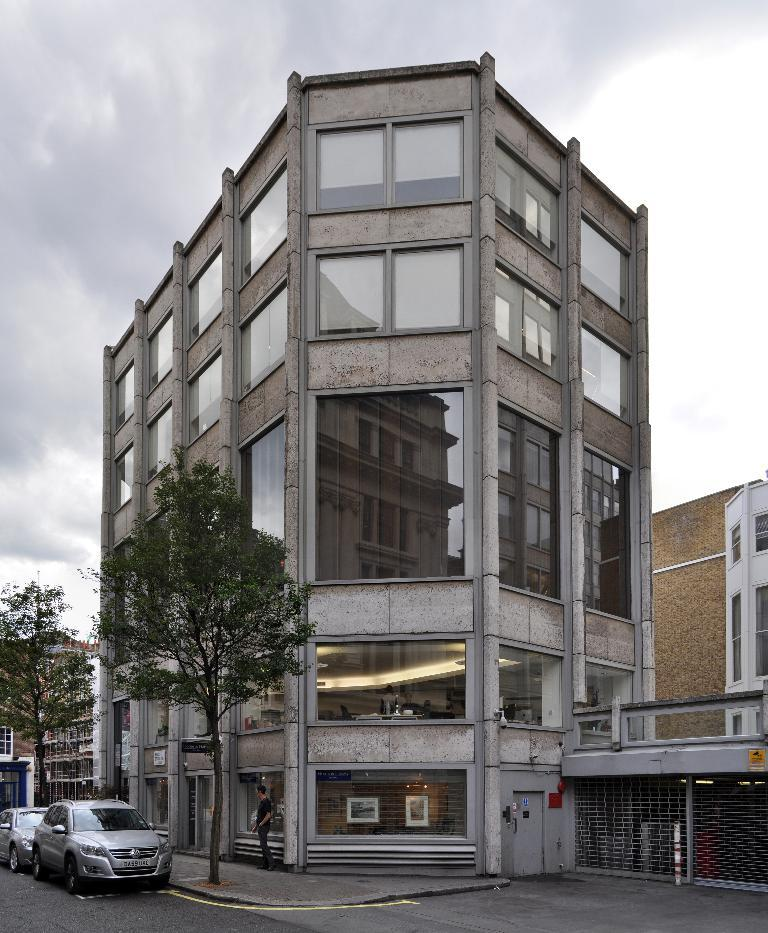What is the main structure in the picture? There is a building in the picture. What else can be seen near the building? There are two vehicles beside the building. Are there any plants visible in the image? Yes, there are two trees on the footpath. What type of fish can be seen swimming in the water near the building? There is no water or fish visible in the image; it features a building, vehicles, and trees. 